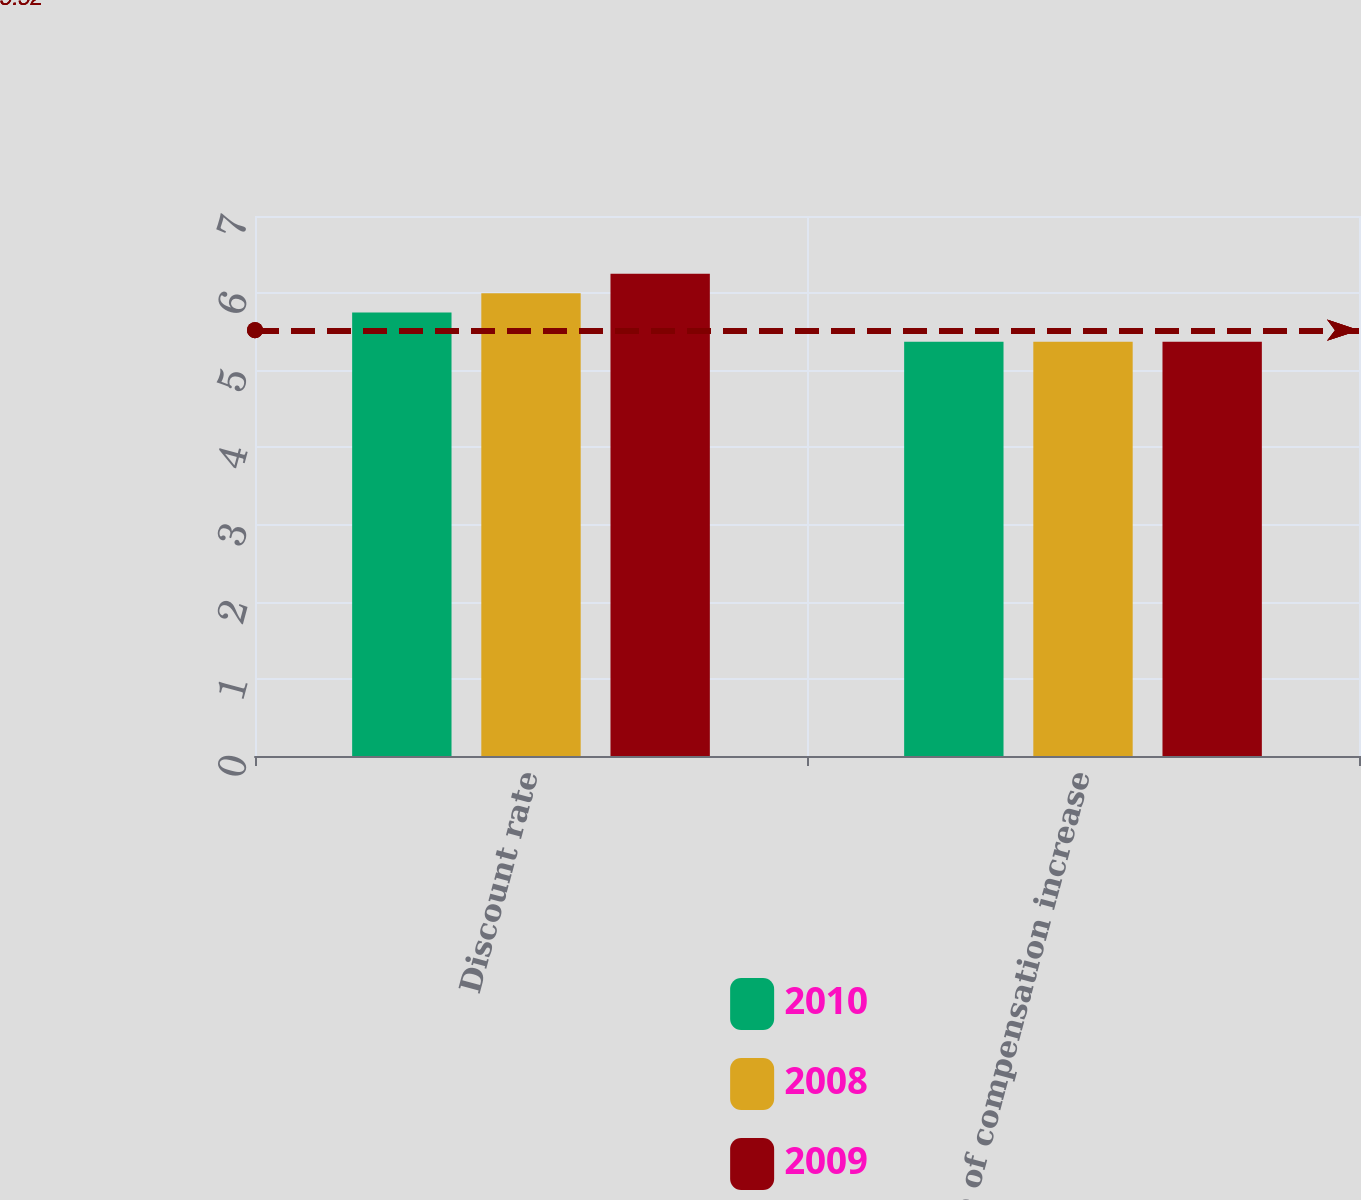Convert chart to OTSL. <chart><loc_0><loc_0><loc_500><loc_500><stacked_bar_chart><ecel><fcel>Discount rate<fcel>Rate of compensation increase<nl><fcel>2010<fcel>5.75<fcel>5.37<nl><fcel>2008<fcel>6<fcel>5.37<nl><fcel>2009<fcel>6.25<fcel>5.37<nl></chart> 